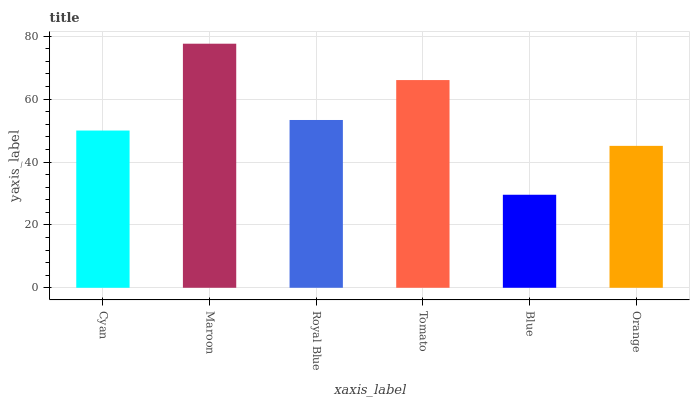Is Maroon the maximum?
Answer yes or no. Yes. Is Royal Blue the minimum?
Answer yes or no. No. Is Royal Blue the maximum?
Answer yes or no. No. Is Maroon greater than Royal Blue?
Answer yes or no. Yes. Is Royal Blue less than Maroon?
Answer yes or no. Yes. Is Royal Blue greater than Maroon?
Answer yes or no. No. Is Maroon less than Royal Blue?
Answer yes or no. No. Is Royal Blue the high median?
Answer yes or no. Yes. Is Cyan the low median?
Answer yes or no. Yes. Is Blue the high median?
Answer yes or no. No. Is Royal Blue the low median?
Answer yes or no. No. 